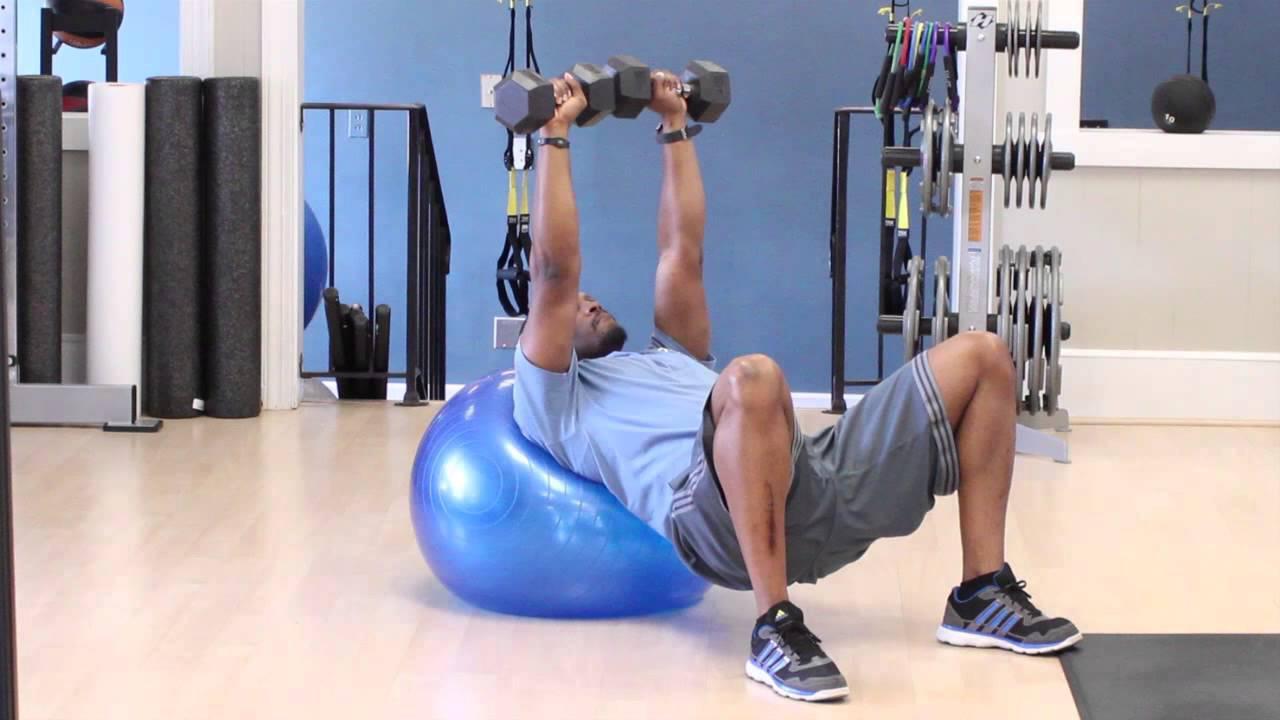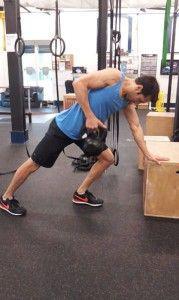The first image is the image on the left, the second image is the image on the right. Analyze the images presented: Is the assertion "Three women are sitting on exercise balls in one of the images." valid? Answer yes or no. No. The first image is the image on the left, the second image is the image on the right. Given the left and right images, does the statement "An image shows three pale-haired women sitting on pink exercise balls." hold true? Answer yes or no. No. 